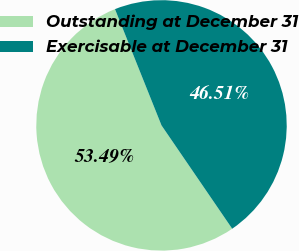Convert chart. <chart><loc_0><loc_0><loc_500><loc_500><pie_chart><fcel>Outstanding at December 31<fcel>Exercisable at December 31<nl><fcel>53.49%<fcel>46.51%<nl></chart> 